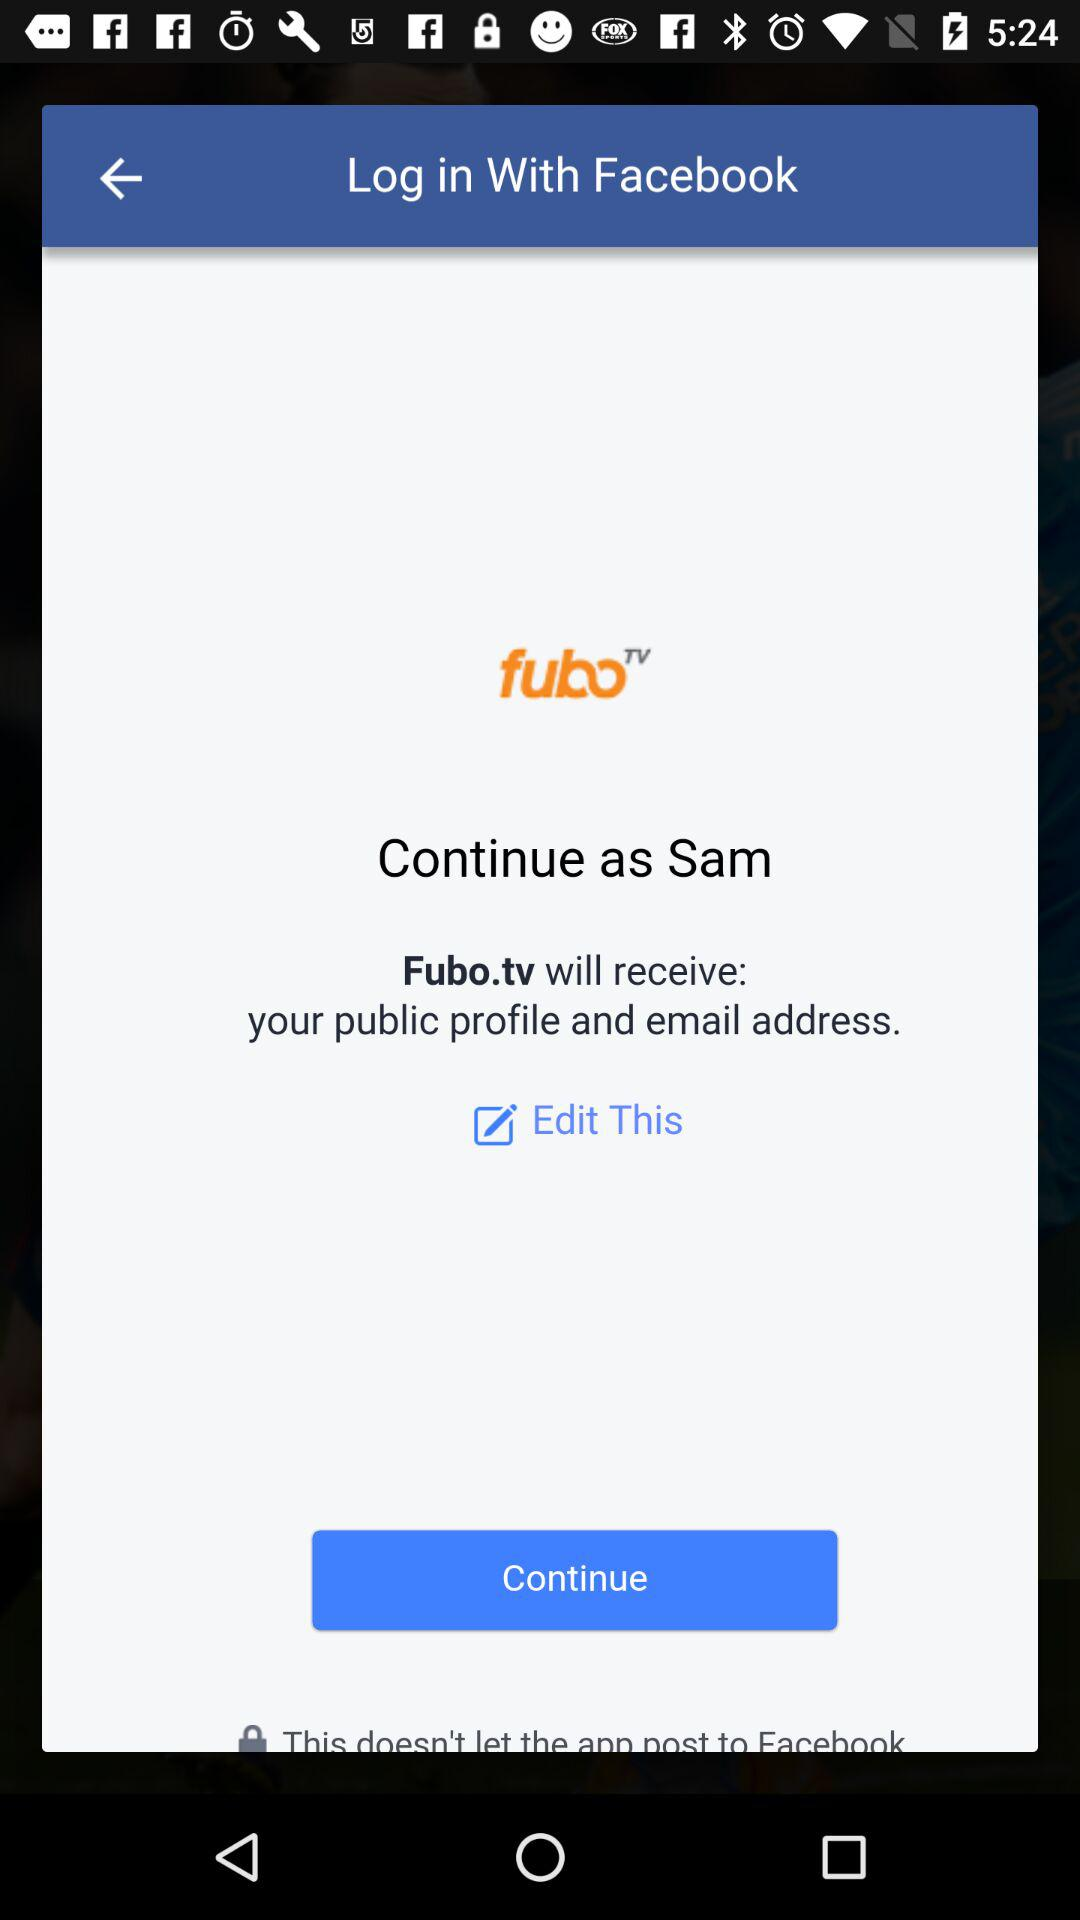What application is asking for permission? The application asking for permission is "Fubo.tv". 